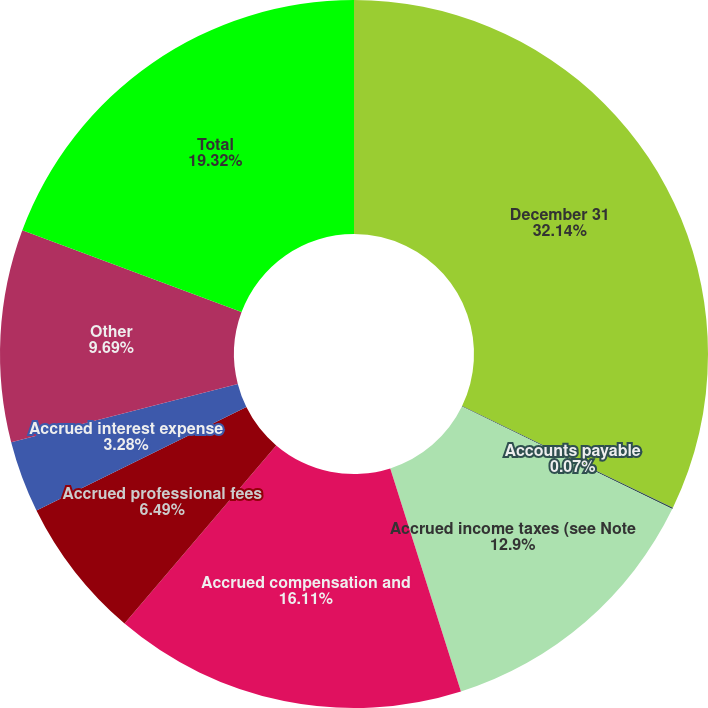Convert chart to OTSL. <chart><loc_0><loc_0><loc_500><loc_500><pie_chart><fcel>December 31<fcel>Accounts payable<fcel>Accrued income taxes (see Note<fcel>Accrued compensation and<fcel>Accrued professional fees<fcel>Accrued interest expense<fcel>Other<fcel>Total<nl><fcel>32.15%<fcel>0.07%<fcel>12.9%<fcel>16.11%<fcel>6.49%<fcel>3.28%<fcel>9.69%<fcel>19.32%<nl></chart> 